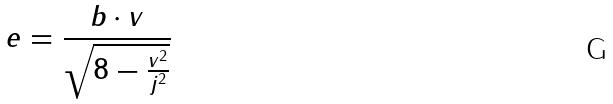Convert formula to latex. <formula><loc_0><loc_0><loc_500><loc_500>e = \frac { b \cdot v } { \sqrt { 8 - \frac { v ^ { 2 } } { j ^ { 2 } } } }</formula> 